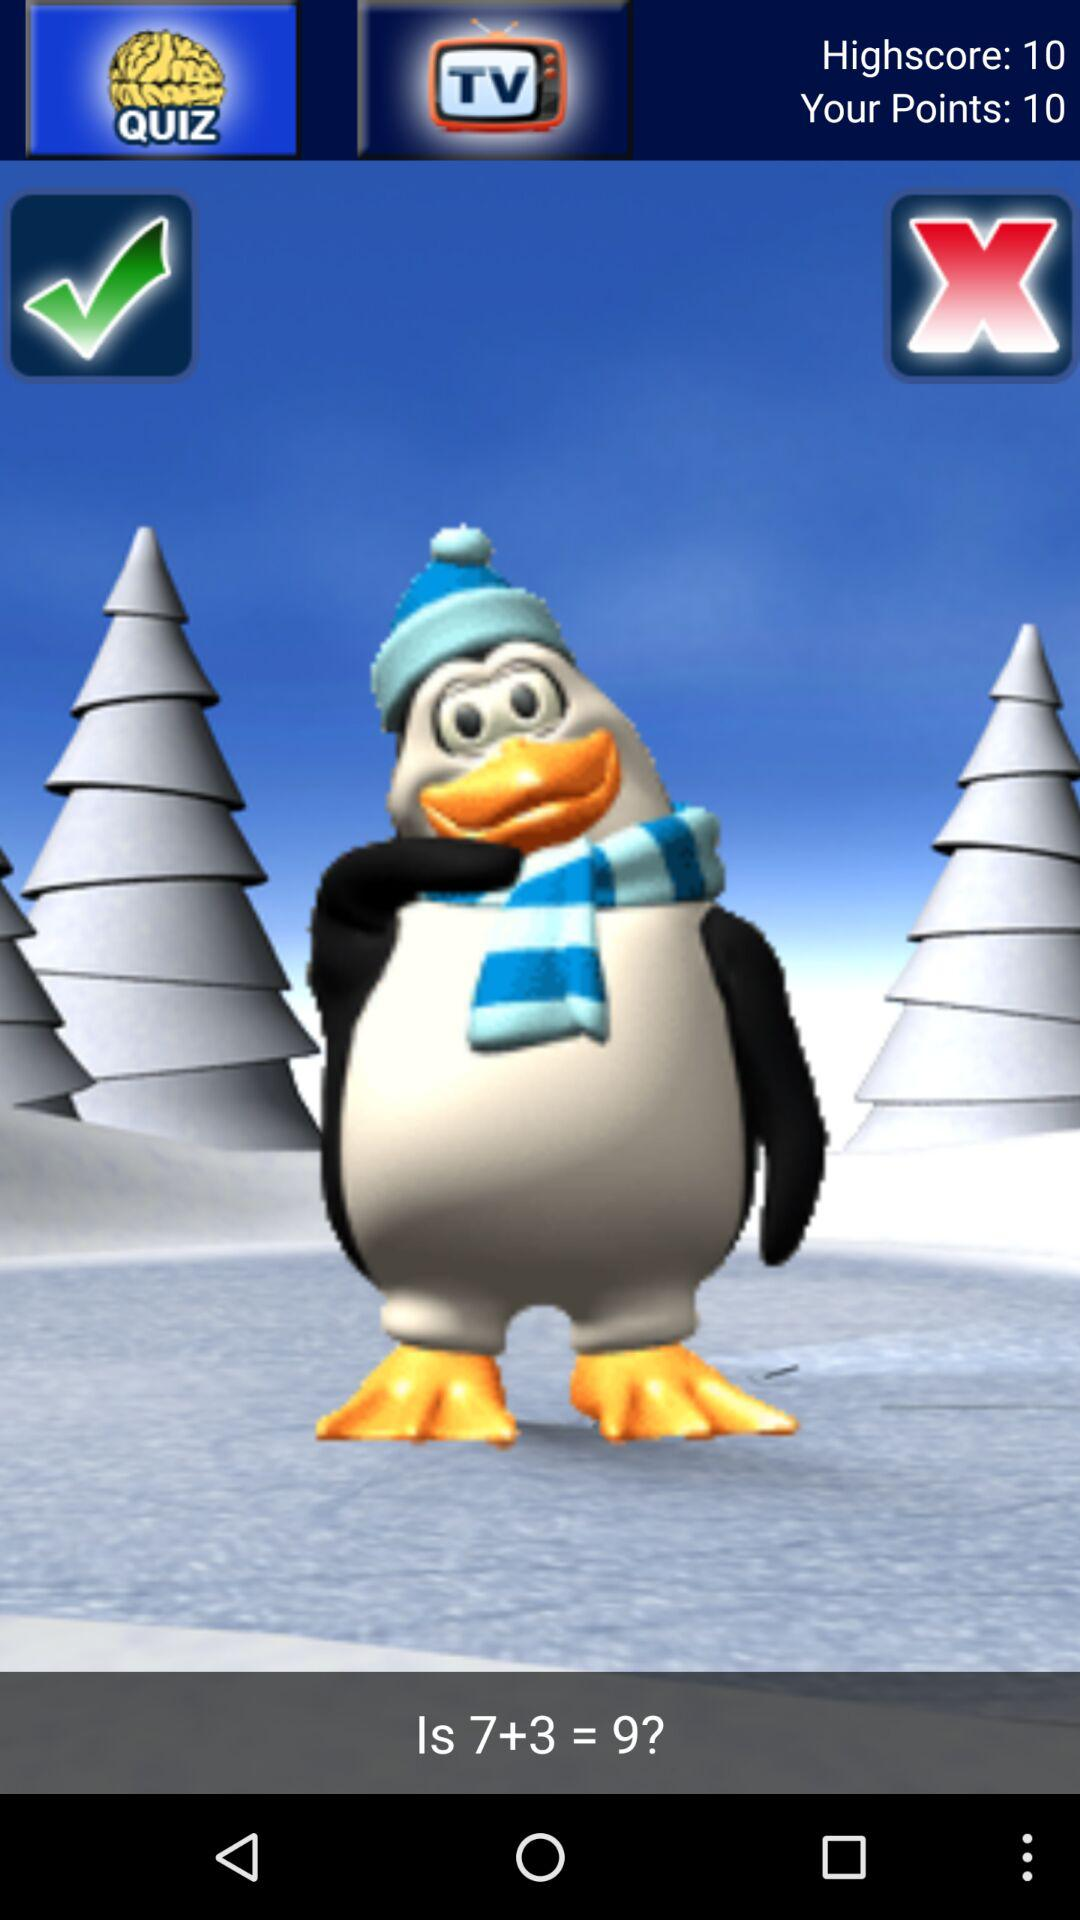How many points higher is the highscore than the current score?
Answer the question using a single word or phrase. 0 